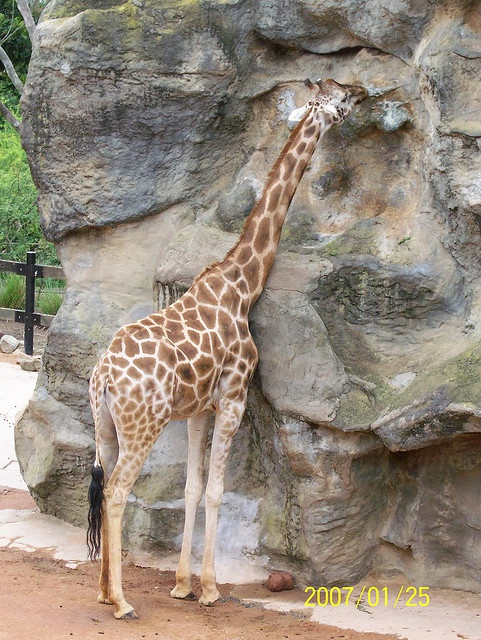Describe the objects in this image and their specific colors. I can see a giraffe in darkgreen, gray, tan, and lightgray tones in this image. 